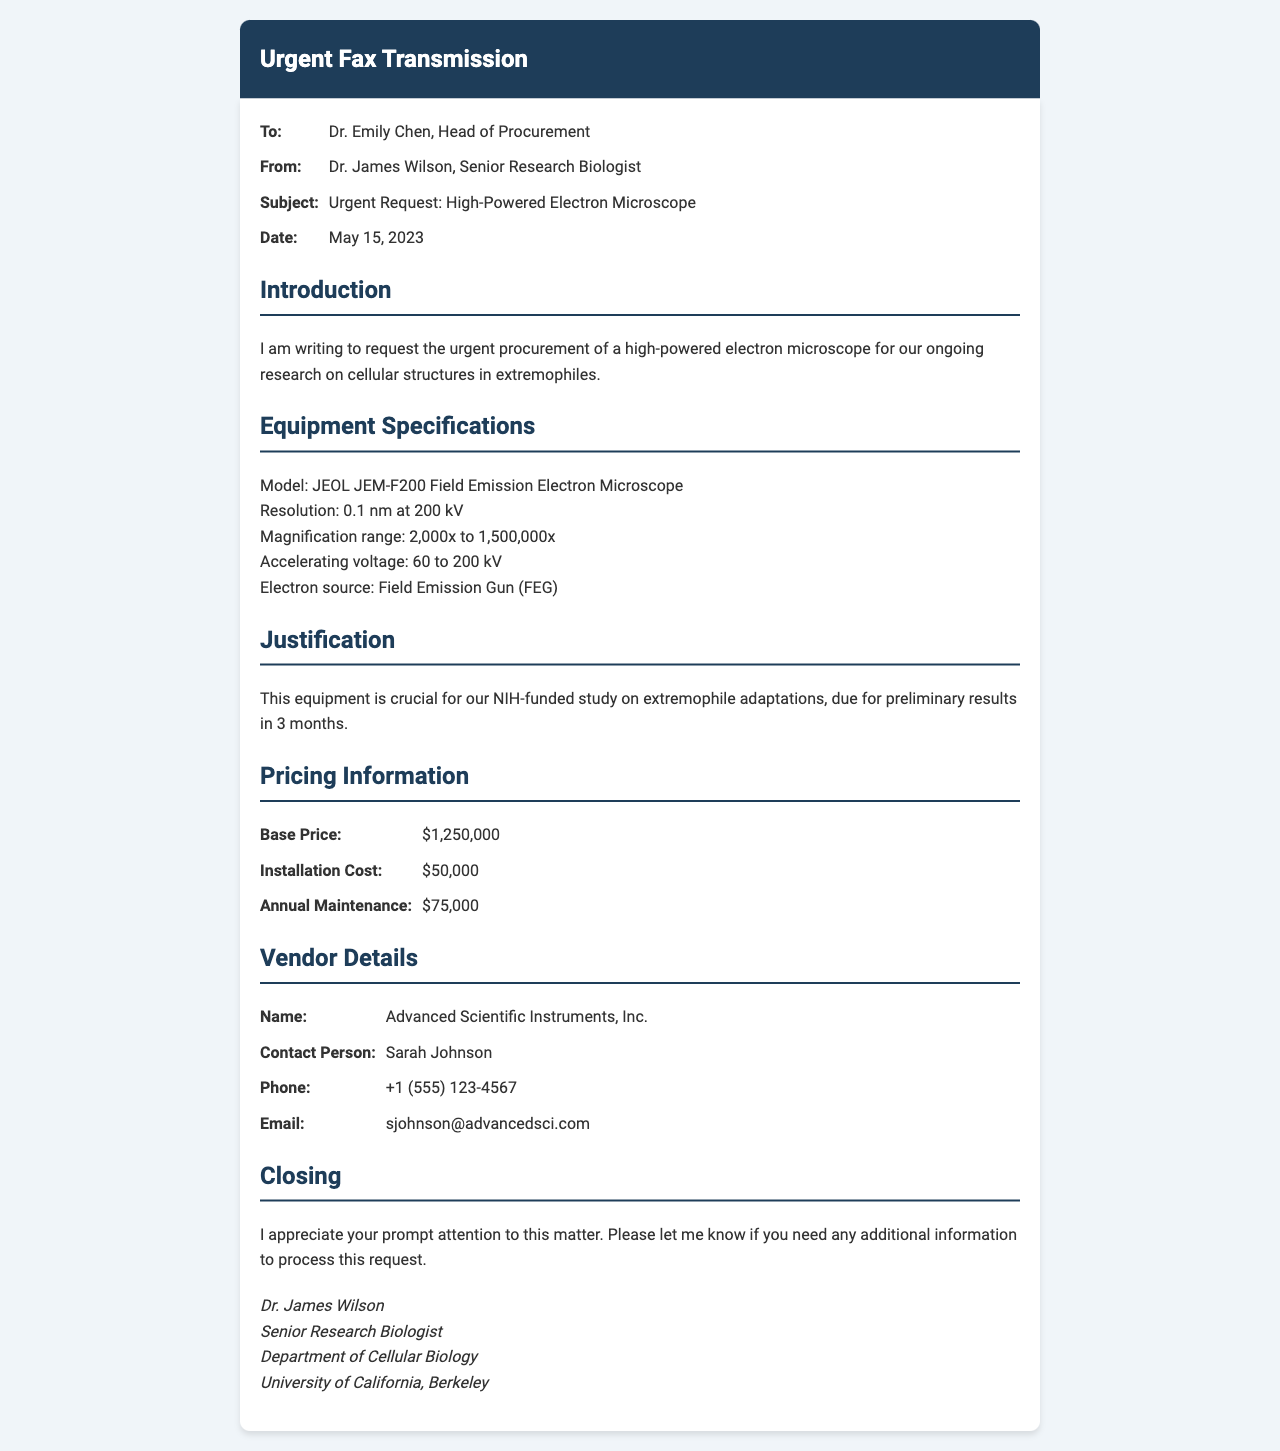what is the model of the electron microscope? The model of the electron microscope is mentioned in the specifications section of the document.
Answer: JEOL JEM-F200 Field Emission Electron Microscope what is the accelerating voltage range? The accelerating voltage range can be found in the specifications section of the document detailing the equipment.
Answer: 60 to 200 kV who is the contact person for the vendor? The contact person is specified in the vendor details section of the document.
Answer: Sarah Johnson what is the base price of the microscope? The base price is listed under the pricing information section of the document.
Answer: $1,250,000 how long do they have to produce preliminary results? The timeframe for preliminary results is mentioned in the justification section of the document.
Answer: 3 months what department does the sender belong to? The sender's department is stated in the closing section of the document.
Answer: Department of Cellular Biology what is the annual maintenance cost? The annual maintenance cost is provided in the pricing information section of the document.
Answer: $75,000 what is the purpose of sending this fax? The purpose is outlined in the introduction section of the document regarding research needs.
Answer: Urgent procurement of a high-powered electron microscope when was the fax sent? The date of the fax is clearly stated in the header information section of the document.
Answer: May 15, 2023 